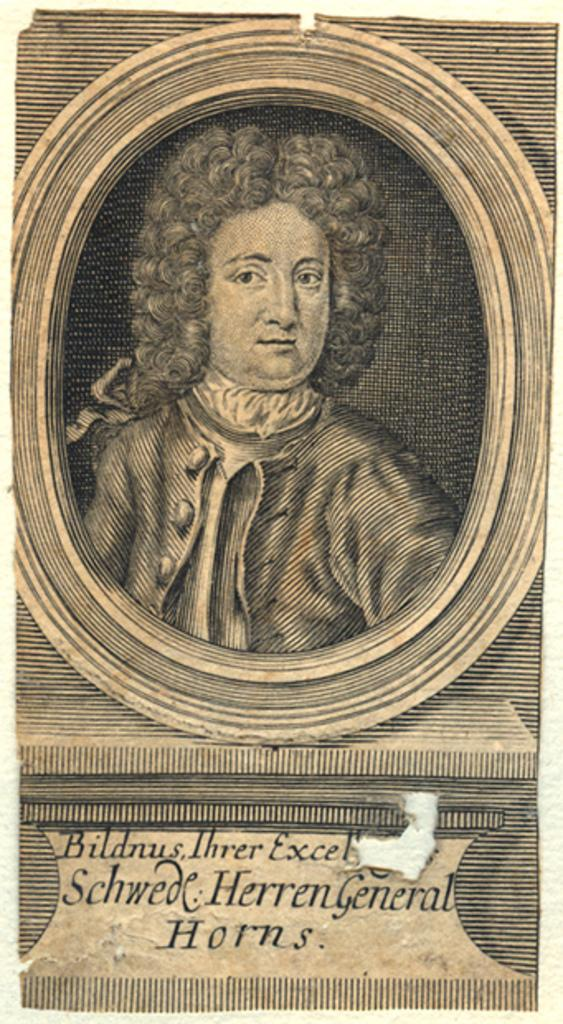<image>
Provide a brief description of the given image. An antique picture of Ihrer Bildnus, Schwede Herren General Horns can be seen 